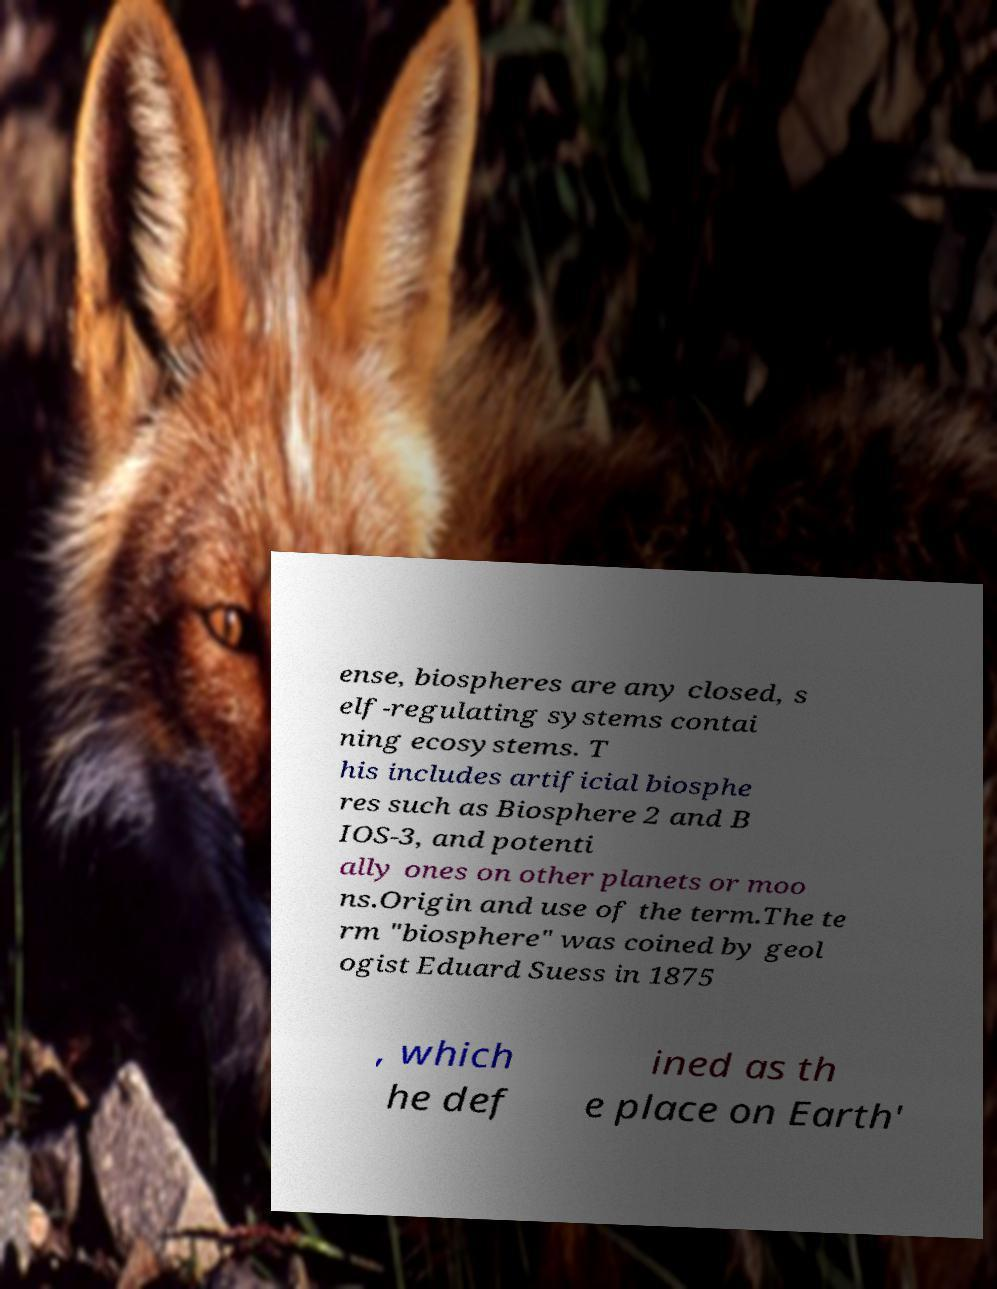Please identify and transcribe the text found in this image. ense, biospheres are any closed, s elf-regulating systems contai ning ecosystems. T his includes artificial biosphe res such as Biosphere 2 and B IOS-3, and potenti ally ones on other planets or moo ns.Origin and use of the term.The te rm "biosphere" was coined by geol ogist Eduard Suess in 1875 , which he def ined as th e place on Earth' 